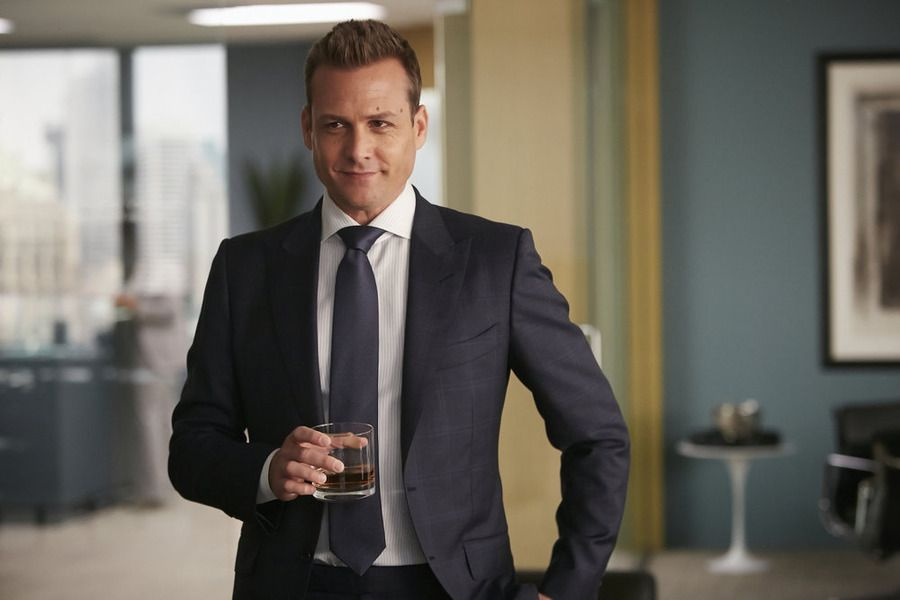Can you describe the character's personality based on this image? Based on the image, the character appears to be confident and authoritative, likely someone who holds a significant position or wields influence. His attire, a dark blue suit, suggests a professional and meticulous nature. The relaxed yet confident stance, combined with the glass of whiskey, indicates a person who is composed and in control, possibly enjoying a moment of reflection or decision-making. The modern office setting further implies that he is successful and accustomed to a sophisticated environment. 